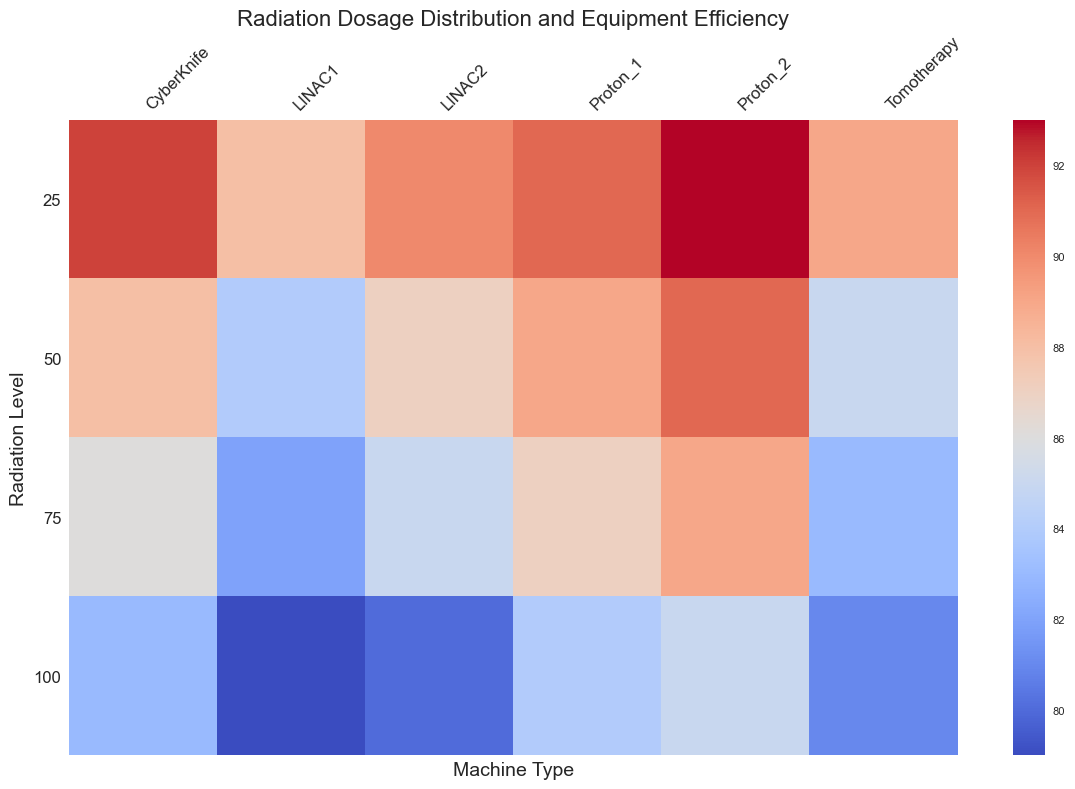How does the efficiency of LINAC1 compare to Proton_1 at a radiation level of 50? Look at the heatmap for the intersection of LINAC1 and 50, and then compare it with the intersection of Proton_1 and 50. LINAC1's efficiency is 84, while Proton_1's is 89.
Answer: Proton_1 is more efficient Which machine has the highest efficiency at a radiation level of 25? Find the column that corresponds to the radiation level of 25 and look for the cell with the highest value in that column. The highest efficiency at this level is 93, attributed to Proton_2.
Answer: Proton_2 What is the average efficiency of CyberKnife across all radiation levels? Add the efficiency values for CyberKnife across all radiation levels (92 + 88 + 86 + 83) and then divide by the number of values, which is 4. So, (92 + 88 + 86 + 83) / 4 = 87.25.
Answer: 87.25 Which machine type shows the least efficiency decline from 25 to 100 radiation levels? Calculate the difference in efficiency between 25 and 100 radiation levels for each machine type, and find the smallest difference. For LINAC1: 88 - 79 = 9, for LINAC2: 90 - 80 = 10, for CyberKnife: 92 - 83 = 9, for Tomotherapy: 89 - 81 = 8, for Proton_1: 91 - 84 = 7, and for Proton_2: 93 - 85 = 8. The least decline is for Proton_1, which is 7.
Answer: Proton_1 What color represents the highest efficiency in the heatmap? Identify the color associated with the highest numeric value in the heatmap. The highest efficiency is 93, and it is represented by the brightest red.
Answer: Bright red How many machines have an efficiency of 87 at any given radiation level? Look across the entire heatmap for the value 87 and count how many times it appears. It appears 3 times, found within LINAC2 at 50, Proton_1 at 50, and Proton_2 at 75.
Answer: 3 At which radiation level do Proton machines (Proton_1 and Proton_2) show the same efficiency? Identify the radiation levels where Proton_1 and Proton_2 have the same efficiency values by comparing their cells across different levels. They both show an efficiency of 85 at a radiation level of 100.
Answer: 100 Which machine is the least efficient at 100 radiation levels? Look at the column for 100 radiation levels and identify the cell with the lowest efficiency. LINAC1 has the lowest efficiency at this level with a value of 79.
Answer: LINAC1 